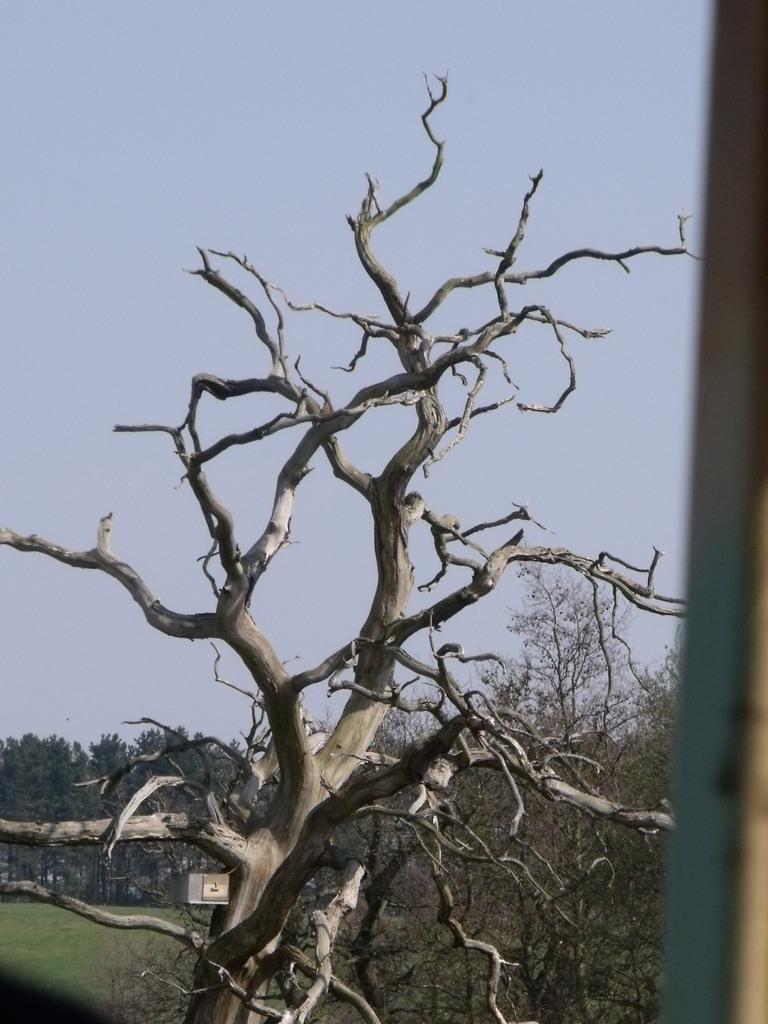Describe this image in one or two sentences. This picture is clicked outside. In the center we can see the dry stems and the green grass. On the right corner we can see an object. In the background we can the sky, trees and some other items. 